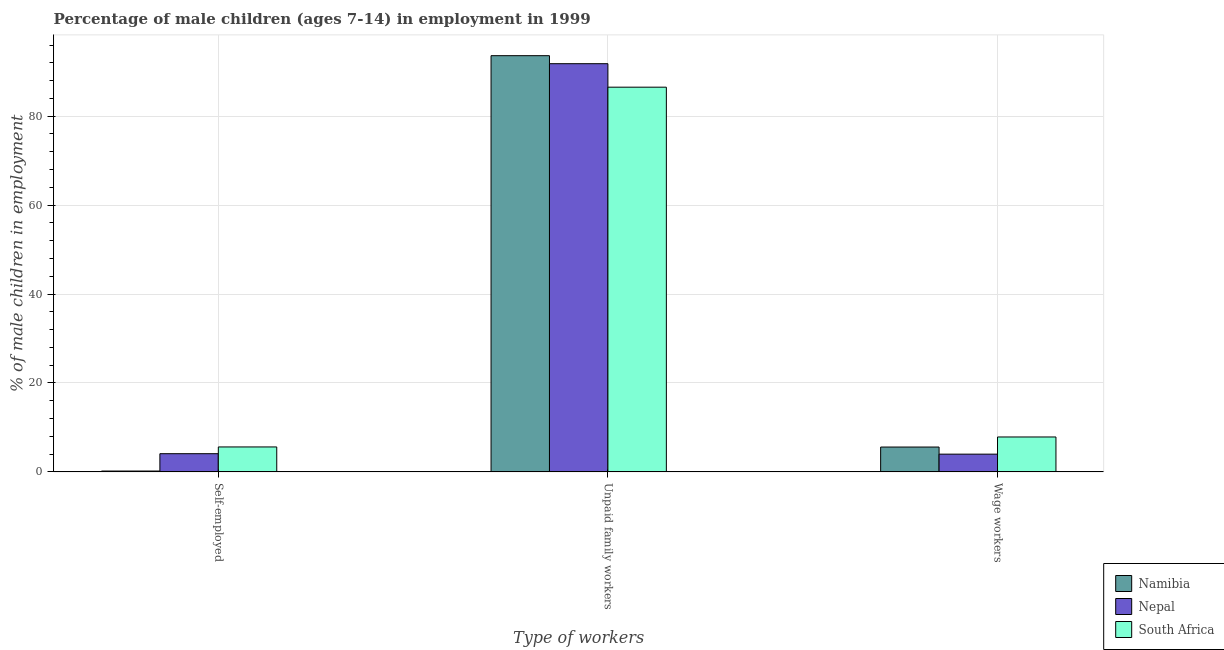How many groups of bars are there?
Give a very brief answer. 3. Are the number of bars on each tick of the X-axis equal?
Your response must be concise. Yes. How many bars are there on the 1st tick from the right?
Provide a short and direct response. 3. What is the label of the 2nd group of bars from the left?
Your answer should be very brief. Unpaid family workers. What is the percentage of self employed children in Nepal?
Make the answer very short. 4.1. Across all countries, what is the maximum percentage of self employed children?
Your response must be concise. 5.62. Across all countries, what is the minimum percentage of children employed as wage workers?
Provide a short and direct response. 4. In which country was the percentage of self employed children maximum?
Give a very brief answer. South Africa. In which country was the percentage of self employed children minimum?
Give a very brief answer. Namibia. What is the total percentage of self employed children in the graph?
Keep it short and to the point. 9.92. What is the difference between the percentage of self employed children in South Africa and that in Nepal?
Offer a terse response. 1.52. What is the difference between the percentage of children employed as unpaid family workers in South Africa and the percentage of children employed as wage workers in Nepal?
Make the answer very short. 82.52. What is the average percentage of self employed children per country?
Provide a succinct answer. 3.31. What is the difference between the percentage of children employed as unpaid family workers and percentage of children employed as wage workers in Namibia?
Provide a short and direct response. 88. In how many countries, is the percentage of children employed as wage workers greater than 24 %?
Offer a terse response. 0. What is the ratio of the percentage of self employed children in South Africa to that in Nepal?
Your answer should be very brief. 1.37. Is the percentage of self employed children in Nepal less than that in Namibia?
Your response must be concise. No. What is the difference between the highest and the second highest percentage of self employed children?
Give a very brief answer. 1.52. What is the difference between the highest and the lowest percentage of children employed as wage workers?
Provide a short and direct response. 3.86. In how many countries, is the percentage of children employed as wage workers greater than the average percentage of children employed as wage workers taken over all countries?
Keep it short and to the point. 1. What does the 1st bar from the left in Wage workers represents?
Provide a succinct answer. Namibia. What does the 1st bar from the right in Self-employed represents?
Offer a very short reply. South Africa. Is it the case that in every country, the sum of the percentage of self employed children and percentage of children employed as unpaid family workers is greater than the percentage of children employed as wage workers?
Offer a terse response. Yes. How many bars are there?
Provide a short and direct response. 9. Are all the bars in the graph horizontal?
Your answer should be compact. No. How many countries are there in the graph?
Provide a short and direct response. 3. Are the values on the major ticks of Y-axis written in scientific E-notation?
Ensure brevity in your answer.  No. Where does the legend appear in the graph?
Give a very brief answer. Bottom right. How many legend labels are there?
Make the answer very short. 3. How are the legend labels stacked?
Provide a succinct answer. Vertical. What is the title of the graph?
Offer a terse response. Percentage of male children (ages 7-14) in employment in 1999. What is the label or title of the X-axis?
Your answer should be compact. Type of workers. What is the label or title of the Y-axis?
Make the answer very short. % of male children in employment. What is the % of male children in employment of Namibia in Self-employed?
Your answer should be compact. 0.2. What is the % of male children in employment in Nepal in Self-employed?
Keep it short and to the point. 4.1. What is the % of male children in employment in South Africa in Self-employed?
Ensure brevity in your answer.  5.62. What is the % of male children in employment of Namibia in Unpaid family workers?
Your response must be concise. 93.6. What is the % of male children in employment in Nepal in Unpaid family workers?
Provide a succinct answer. 91.8. What is the % of male children in employment in South Africa in Unpaid family workers?
Keep it short and to the point. 86.52. What is the % of male children in employment of South Africa in Wage workers?
Provide a short and direct response. 7.86. Across all Type of workers, what is the maximum % of male children in employment in Namibia?
Ensure brevity in your answer.  93.6. Across all Type of workers, what is the maximum % of male children in employment in Nepal?
Provide a succinct answer. 91.8. Across all Type of workers, what is the maximum % of male children in employment of South Africa?
Ensure brevity in your answer.  86.52. Across all Type of workers, what is the minimum % of male children in employment in Namibia?
Your answer should be compact. 0.2. Across all Type of workers, what is the minimum % of male children in employment in South Africa?
Provide a succinct answer. 5.62. What is the total % of male children in employment of Namibia in the graph?
Make the answer very short. 99.4. What is the total % of male children in employment in Nepal in the graph?
Keep it short and to the point. 99.9. What is the total % of male children in employment of South Africa in the graph?
Ensure brevity in your answer.  100. What is the difference between the % of male children in employment in Namibia in Self-employed and that in Unpaid family workers?
Your answer should be very brief. -93.4. What is the difference between the % of male children in employment in Nepal in Self-employed and that in Unpaid family workers?
Your answer should be compact. -87.7. What is the difference between the % of male children in employment in South Africa in Self-employed and that in Unpaid family workers?
Your answer should be compact. -80.9. What is the difference between the % of male children in employment of South Africa in Self-employed and that in Wage workers?
Your answer should be very brief. -2.24. What is the difference between the % of male children in employment in Nepal in Unpaid family workers and that in Wage workers?
Ensure brevity in your answer.  87.8. What is the difference between the % of male children in employment of South Africa in Unpaid family workers and that in Wage workers?
Ensure brevity in your answer.  78.66. What is the difference between the % of male children in employment of Namibia in Self-employed and the % of male children in employment of Nepal in Unpaid family workers?
Your response must be concise. -91.6. What is the difference between the % of male children in employment in Namibia in Self-employed and the % of male children in employment in South Africa in Unpaid family workers?
Offer a terse response. -86.32. What is the difference between the % of male children in employment of Nepal in Self-employed and the % of male children in employment of South Africa in Unpaid family workers?
Your answer should be compact. -82.42. What is the difference between the % of male children in employment of Namibia in Self-employed and the % of male children in employment of Nepal in Wage workers?
Your answer should be very brief. -3.8. What is the difference between the % of male children in employment in Namibia in Self-employed and the % of male children in employment in South Africa in Wage workers?
Your answer should be compact. -7.66. What is the difference between the % of male children in employment of Nepal in Self-employed and the % of male children in employment of South Africa in Wage workers?
Provide a short and direct response. -3.76. What is the difference between the % of male children in employment of Namibia in Unpaid family workers and the % of male children in employment of Nepal in Wage workers?
Ensure brevity in your answer.  89.6. What is the difference between the % of male children in employment of Namibia in Unpaid family workers and the % of male children in employment of South Africa in Wage workers?
Your answer should be compact. 85.74. What is the difference between the % of male children in employment in Nepal in Unpaid family workers and the % of male children in employment in South Africa in Wage workers?
Ensure brevity in your answer.  83.94. What is the average % of male children in employment of Namibia per Type of workers?
Keep it short and to the point. 33.13. What is the average % of male children in employment in Nepal per Type of workers?
Provide a succinct answer. 33.3. What is the average % of male children in employment of South Africa per Type of workers?
Give a very brief answer. 33.33. What is the difference between the % of male children in employment of Namibia and % of male children in employment of Nepal in Self-employed?
Your answer should be very brief. -3.9. What is the difference between the % of male children in employment in Namibia and % of male children in employment in South Africa in Self-employed?
Give a very brief answer. -5.42. What is the difference between the % of male children in employment in Nepal and % of male children in employment in South Africa in Self-employed?
Provide a succinct answer. -1.52. What is the difference between the % of male children in employment in Namibia and % of male children in employment in South Africa in Unpaid family workers?
Provide a succinct answer. 7.08. What is the difference between the % of male children in employment in Nepal and % of male children in employment in South Africa in Unpaid family workers?
Keep it short and to the point. 5.28. What is the difference between the % of male children in employment of Namibia and % of male children in employment of South Africa in Wage workers?
Provide a short and direct response. -2.26. What is the difference between the % of male children in employment of Nepal and % of male children in employment of South Africa in Wage workers?
Provide a short and direct response. -3.86. What is the ratio of the % of male children in employment in Namibia in Self-employed to that in Unpaid family workers?
Keep it short and to the point. 0. What is the ratio of the % of male children in employment in Nepal in Self-employed to that in Unpaid family workers?
Your response must be concise. 0.04. What is the ratio of the % of male children in employment of South Africa in Self-employed to that in Unpaid family workers?
Ensure brevity in your answer.  0.07. What is the ratio of the % of male children in employment of Namibia in Self-employed to that in Wage workers?
Give a very brief answer. 0.04. What is the ratio of the % of male children in employment in South Africa in Self-employed to that in Wage workers?
Give a very brief answer. 0.71. What is the ratio of the % of male children in employment in Namibia in Unpaid family workers to that in Wage workers?
Your answer should be very brief. 16.71. What is the ratio of the % of male children in employment of Nepal in Unpaid family workers to that in Wage workers?
Offer a very short reply. 22.95. What is the ratio of the % of male children in employment in South Africa in Unpaid family workers to that in Wage workers?
Ensure brevity in your answer.  11.01. What is the difference between the highest and the second highest % of male children in employment of Nepal?
Keep it short and to the point. 87.7. What is the difference between the highest and the second highest % of male children in employment of South Africa?
Provide a short and direct response. 78.66. What is the difference between the highest and the lowest % of male children in employment of Namibia?
Your response must be concise. 93.4. What is the difference between the highest and the lowest % of male children in employment of Nepal?
Make the answer very short. 87.8. What is the difference between the highest and the lowest % of male children in employment in South Africa?
Provide a succinct answer. 80.9. 